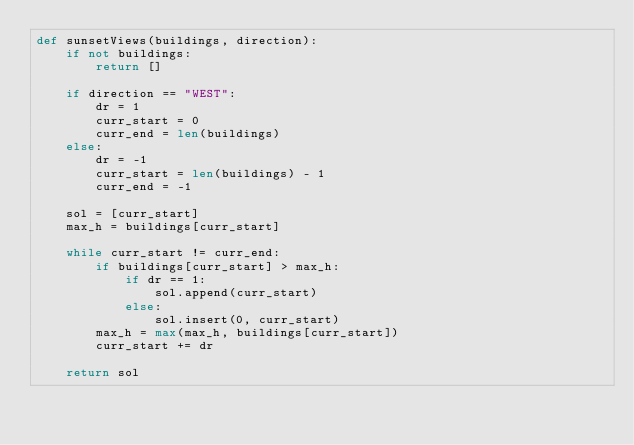Convert code to text. <code><loc_0><loc_0><loc_500><loc_500><_Python_>def sunsetViews(buildings, direction):
    if not buildings:
        return []

    if direction == "WEST":
        dr = 1
        curr_start = 0
        curr_end = len(buildings)
    else:
        dr = -1
        curr_start = len(buildings) - 1
        curr_end = -1

    sol = [curr_start]
    max_h = buildings[curr_start]

    while curr_start != curr_end:
        if buildings[curr_start] > max_h:
            if dr == 1:
                sol.append(curr_start)
            else:
                sol.insert(0, curr_start)
        max_h = max(max_h, buildings[curr_start])
        curr_start += dr

    return sol
</code> 